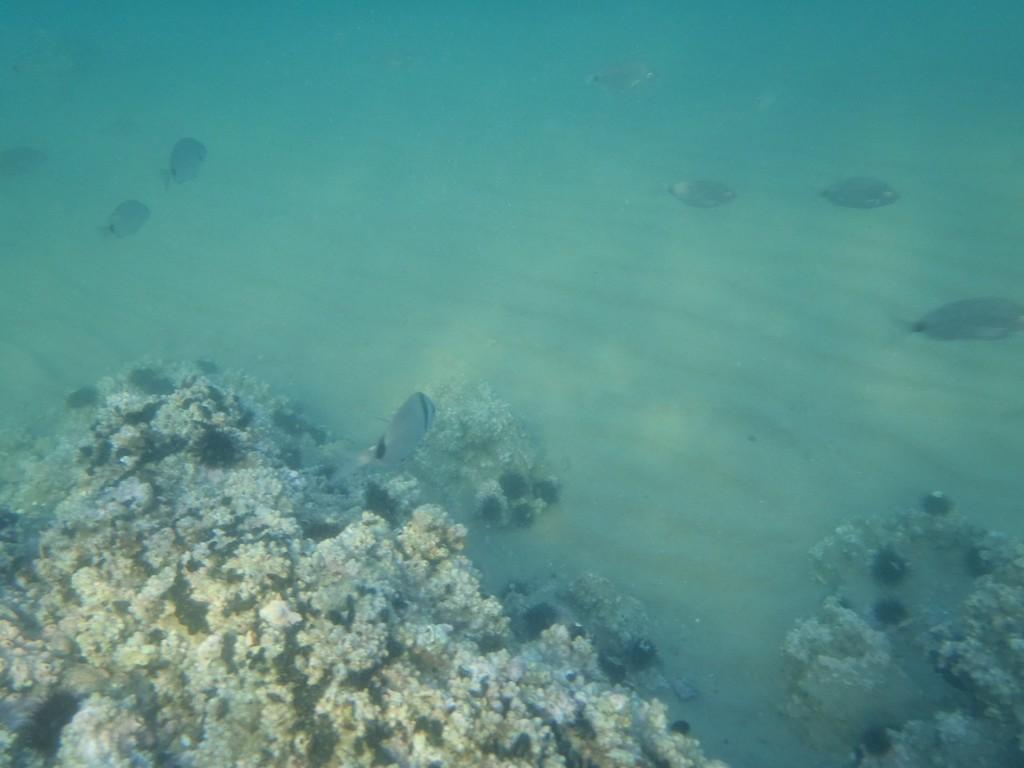What is visible in the image? Water is visible in the image. What can be found in the water? There are corals and fish in the water. Can you see any jellyfish in the image? There is no jellyfish present in the image. What type of needle can be seen in the image? There is no needle present in the image. 